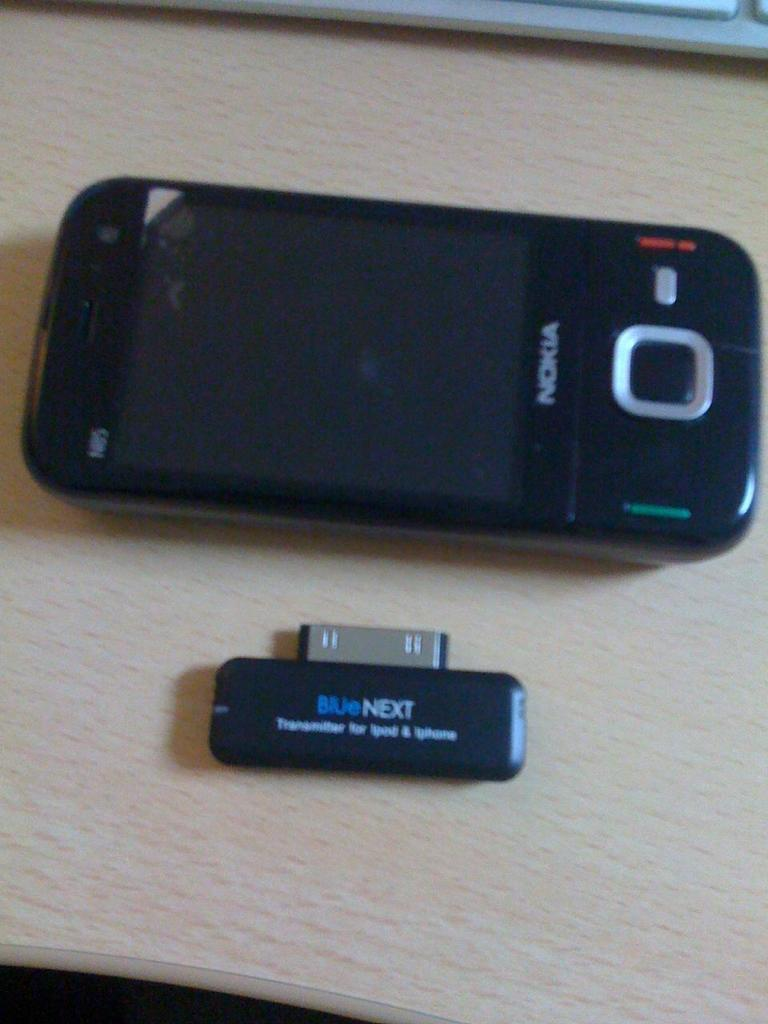<image>
Render a clear and concise summary of the photo. A black nokia phone on a wood table. 